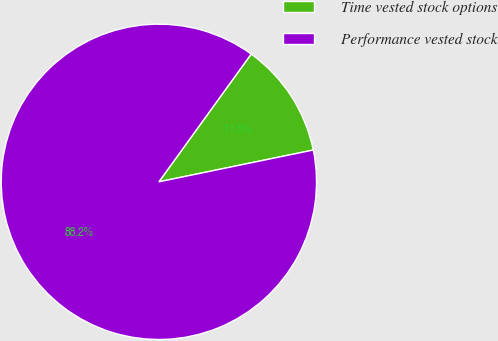Convert chart to OTSL. <chart><loc_0><loc_0><loc_500><loc_500><pie_chart><fcel>Time vested stock options<fcel>Performance vested stock<nl><fcel>11.81%<fcel>88.19%<nl></chart> 